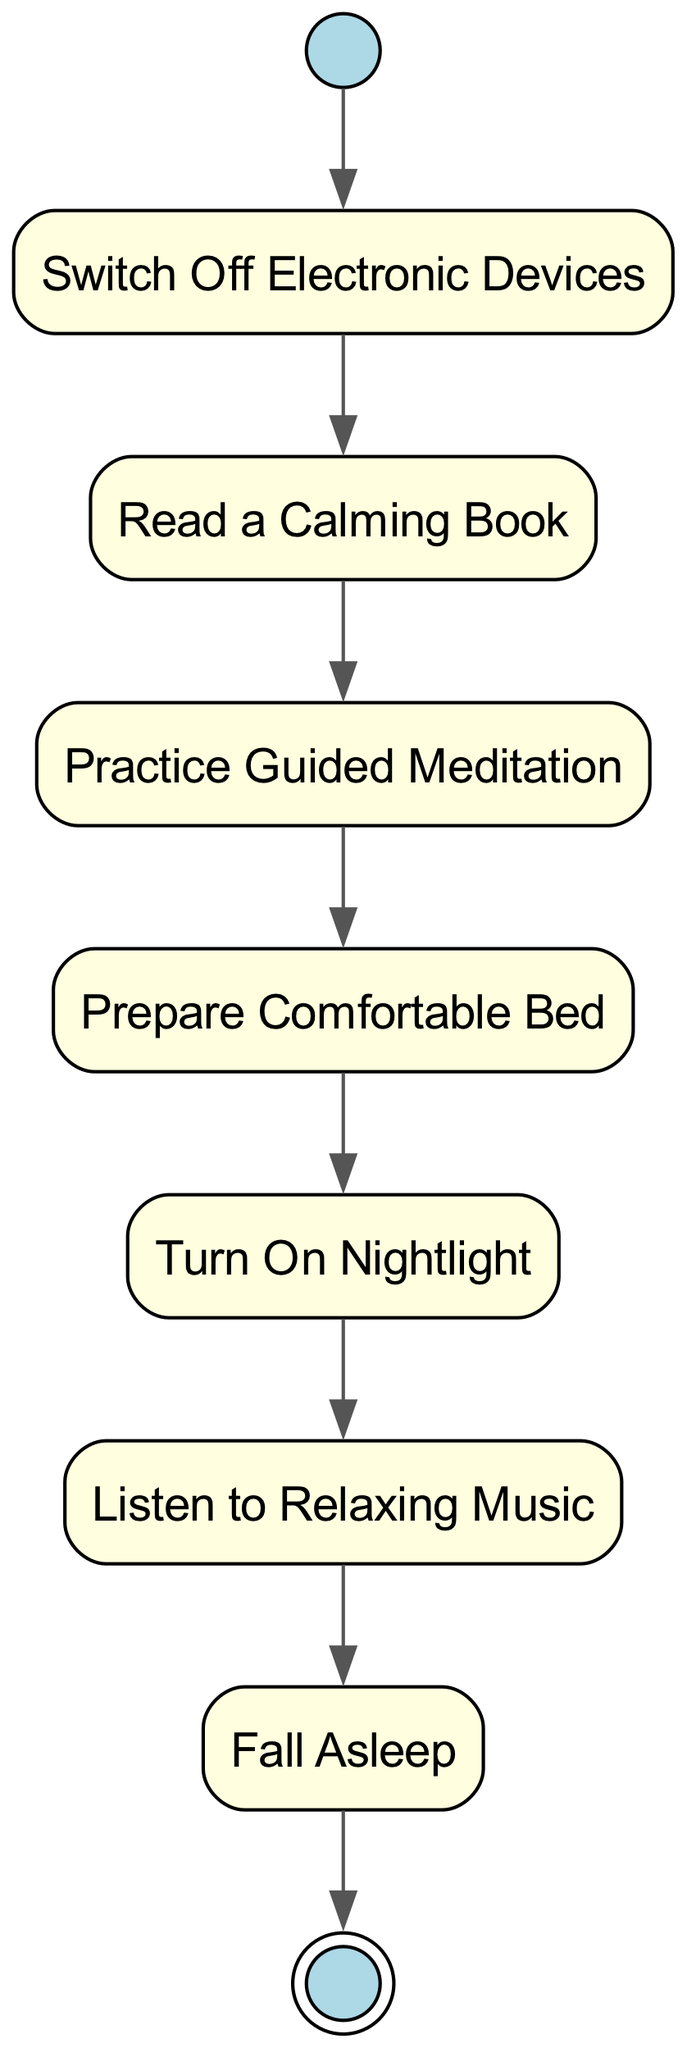What is the starting activity? The diagram begins with the activity labeled "Start," which is the initial node signifying the beginning of the routine.
Answer: Start How many activities are there in total? By counting all the unique nodes in the diagram, including the start and final nodes, we find there are eight activities represented.
Answer: Eight What is the last action before falling asleep? The action that directly precedes "Fall Asleep" is "Listen to Relaxing Music," as indicated by the directed edge leading to "sleep."
Answer: Listen to Relaxing Music Which activity comes after turning on the nightlight? The diagram shows that after "Turn On Nightlight," the next activity is "Listen to Relaxing Music," established by the connecting edge.
Answer: Listen to Relaxing Music What type of diagram is represented? This visual representation is classified as an Activity Diagram, which is used to portray workflows or processes in a step-by-step manner.
Answer: Activity Diagram What connects 'Prepare Comfortable Bed' to the next action? The connection from 'Prepare Comfortable Bed' to the next action is established through a directed edge that leads to 'Turn On Nightlight,' indicating the flow of activities.
Answer: Turn On Nightlight Which activity is classified as a final node? The final activity in this routine is represented by an end node labeled "End," indicating the conclusion of the nighttime anxiety routine.
Answer: End What is the sequence of activities leading to sleep? The sequence of activities leading to "Fall Asleep" starts from "Start" and follows the path: Switch Off Electronic Devices → Read a Calming Book → Practice Guided Meditation → Prepare Comfortable Bed → Turn On Nightlight → Listen to Relaxing Music.
Answer: Switch Off Electronic Devices, Read a Calming Book, Practice Guided Meditation, Prepare Comfortable Bed, Turn On Nightlight, Listen to Relaxing Music 